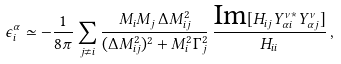Convert formula to latex. <formula><loc_0><loc_0><loc_500><loc_500>\epsilon _ { i } ^ { \alpha } \simeq - \frac { 1 } { 8 \pi } \sum _ { j \neq i } \frac { M _ { i } M _ { j } \, \Delta M _ { i j } ^ { 2 } } { ( \Delta M _ { i j } ^ { 2 } ) ^ { 2 } + M _ { i } ^ { 2 } \Gamma _ { j } ^ { 2 } } \, \frac { \text {Im} [ H _ { i j } Y ^ { \nu * } _ { \alpha i } Y ^ { \nu } _ { \alpha j } ] } { H _ { i i } } \, ,</formula> 